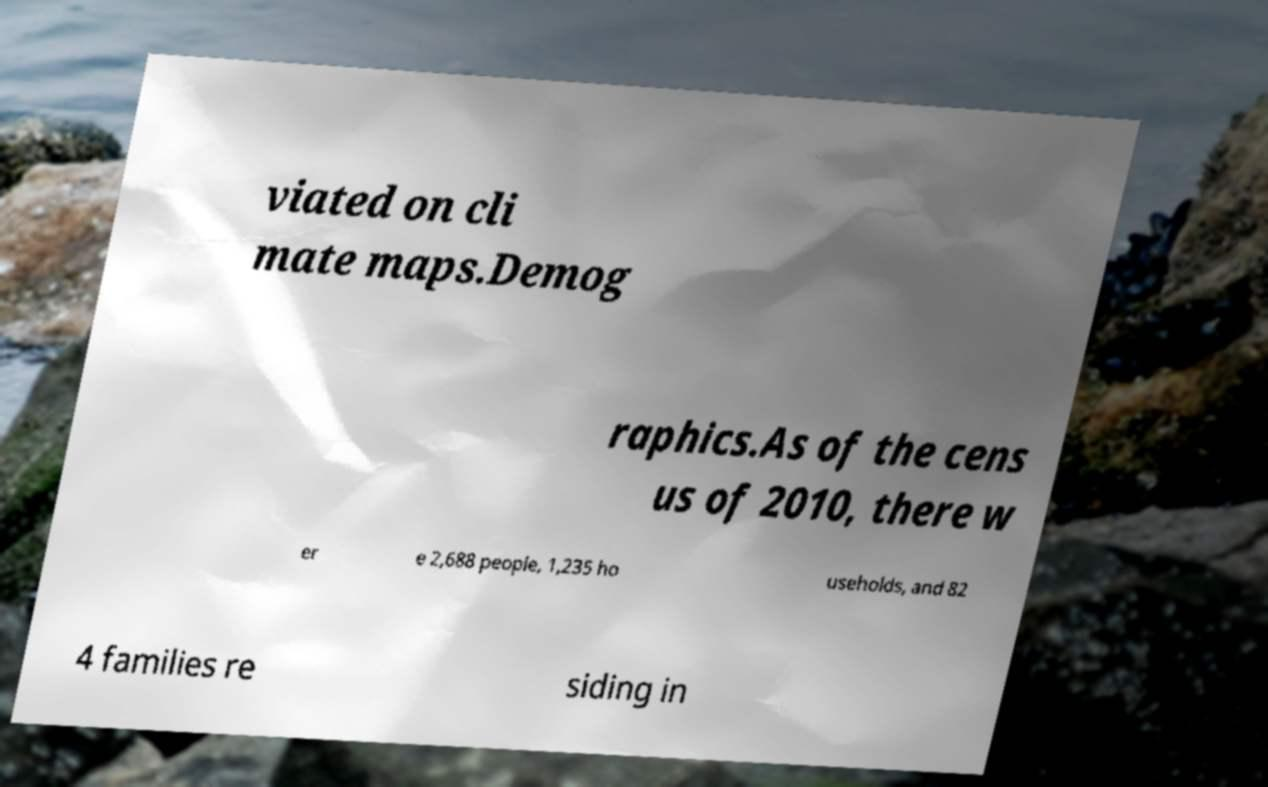For documentation purposes, I need the text within this image transcribed. Could you provide that? viated on cli mate maps.Demog raphics.As of the cens us of 2010, there w er e 2,688 people, 1,235 ho useholds, and 82 4 families re siding in 